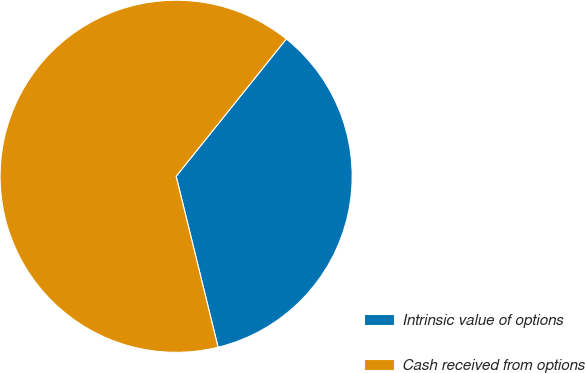<chart> <loc_0><loc_0><loc_500><loc_500><pie_chart><fcel>Intrinsic value of options<fcel>Cash received from options<nl><fcel>35.41%<fcel>64.59%<nl></chart> 